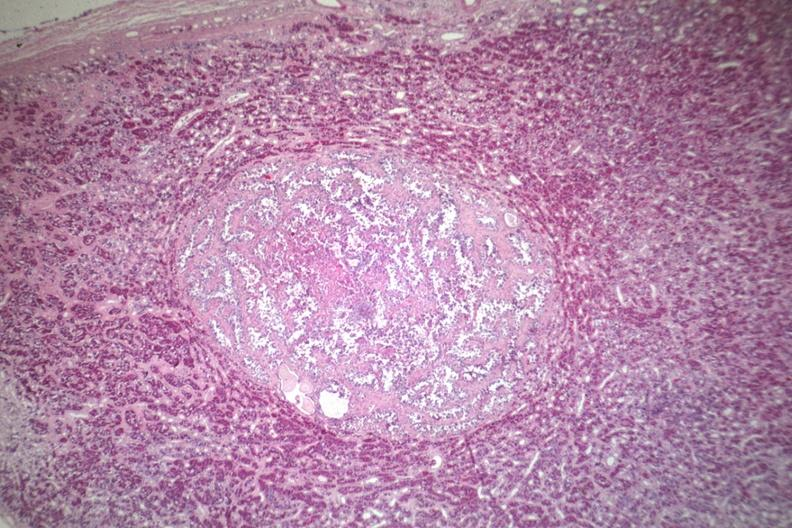s abdomen present?
Answer the question using a single word or phrase. No 